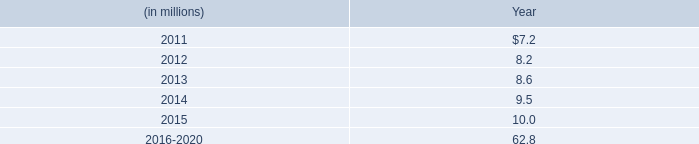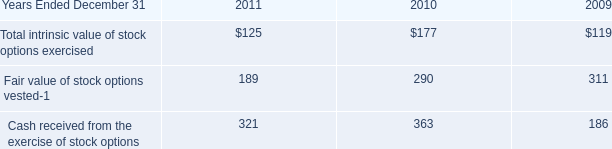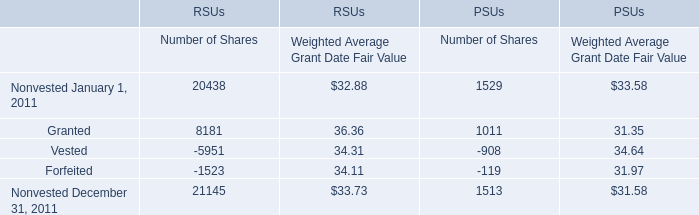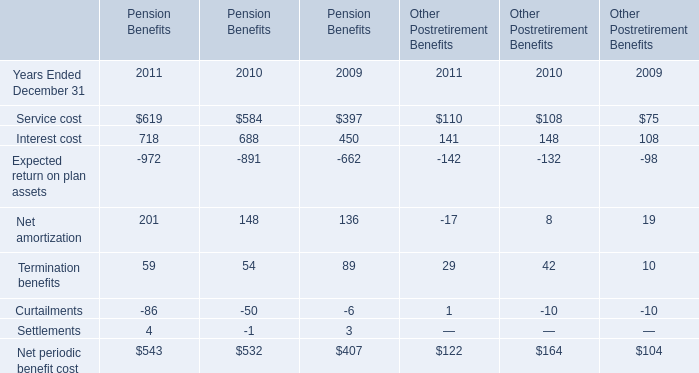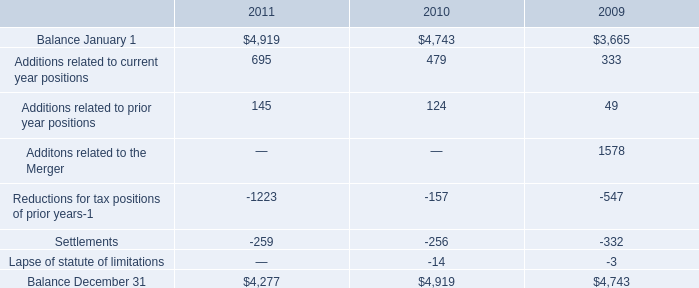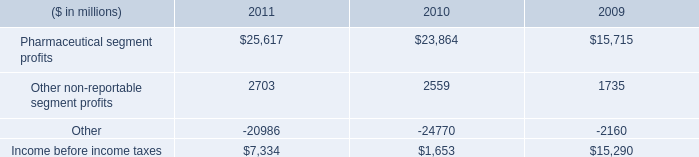what was the average 2010 and 2009 total liability for the mrrp , in millions? 
Computations: ((20.5 + 20.7) / 2)
Answer: 20.6. 